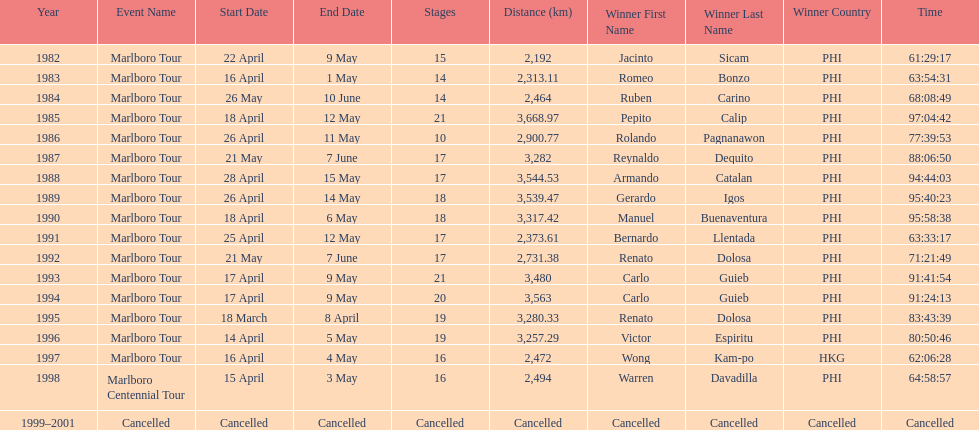Who is listed below romeo bonzo? Ruben Carino (PHI). 